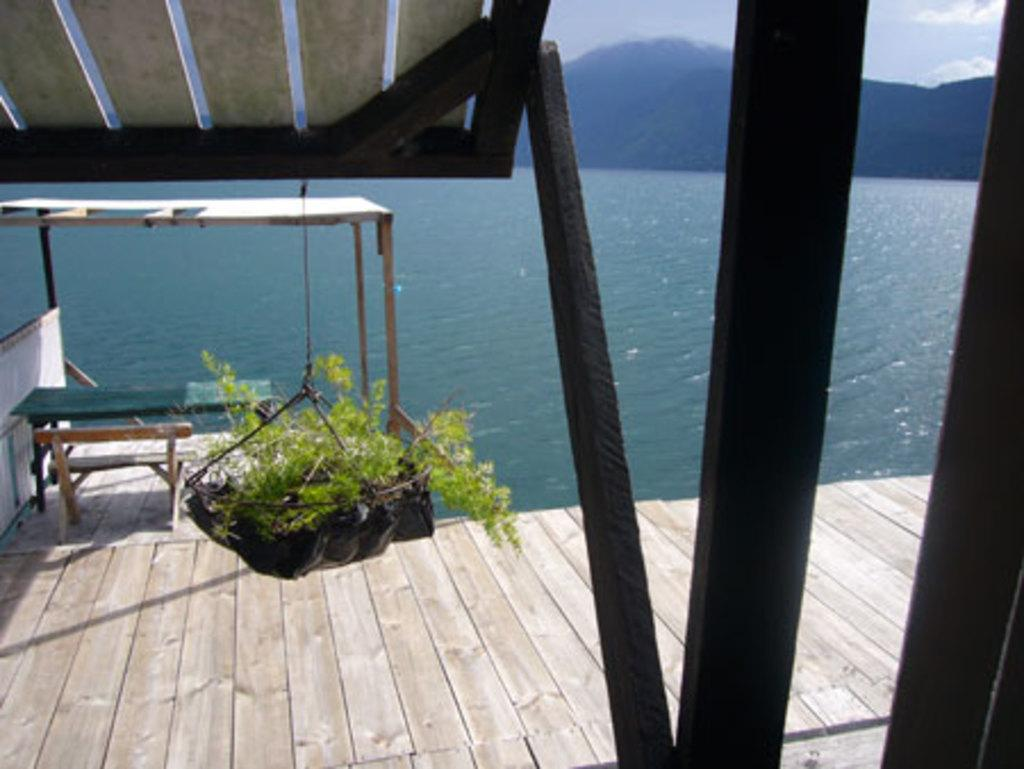What type of natural formation can be seen in the image? There are mountains in the image. What body of water is present in the image? There is a lake in the image. What type of structure is visible in the image? There is a wooden house in the image. What type of outdoor furniture can be seen in the image? There is a bench and a chair in the image. What type of decorative item is hanging in the image? There is a hanging pot in the image. Can you tell me how many ants are crawling on the wooden house in the image? There are no ants present in the image; it features mountains, a lake, a wooden house, a bench, a chair, and a hanging pot. What type of channel is visible in the image? There is no channel present in the image. 